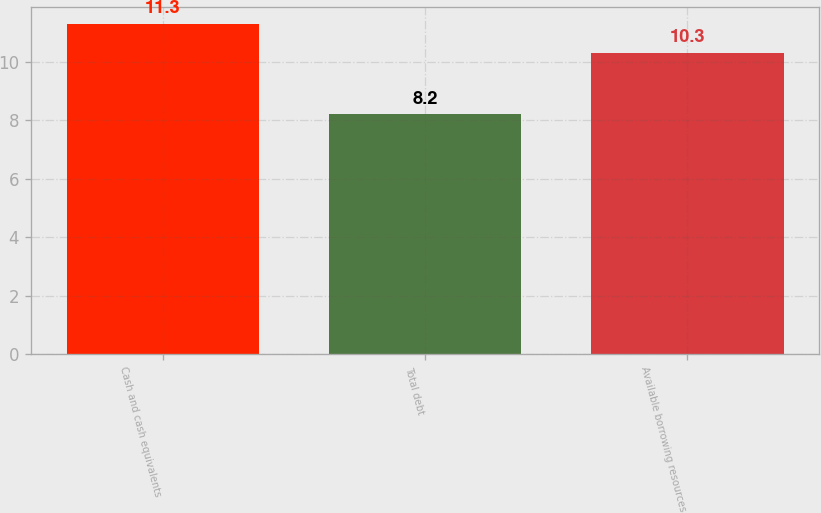Convert chart to OTSL. <chart><loc_0><loc_0><loc_500><loc_500><bar_chart><fcel>Cash and cash equivalents<fcel>Total debt<fcel>Available borrowing resources<nl><fcel>11.3<fcel>8.2<fcel>10.3<nl></chart> 